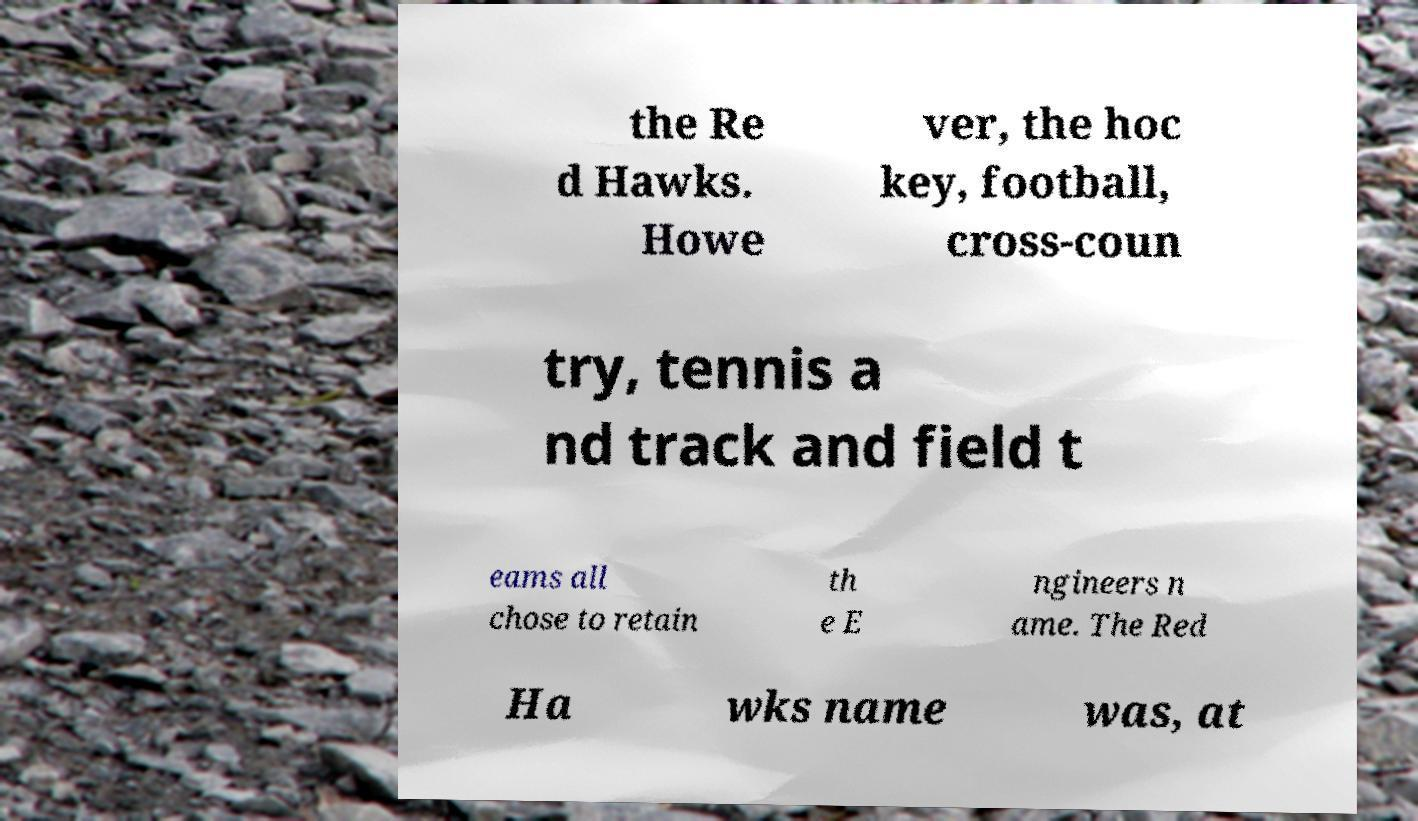There's text embedded in this image that I need extracted. Can you transcribe it verbatim? the Re d Hawks. Howe ver, the hoc key, football, cross-coun try, tennis a nd track and field t eams all chose to retain th e E ngineers n ame. The Red Ha wks name was, at 